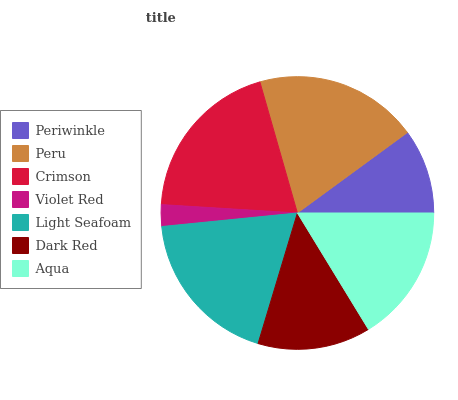Is Violet Red the minimum?
Answer yes or no. Yes. Is Crimson the maximum?
Answer yes or no. Yes. Is Peru the minimum?
Answer yes or no. No. Is Peru the maximum?
Answer yes or no. No. Is Peru greater than Periwinkle?
Answer yes or no. Yes. Is Periwinkle less than Peru?
Answer yes or no. Yes. Is Periwinkle greater than Peru?
Answer yes or no. No. Is Peru less than Periwinkle?
Answer yes or no. No. Is Aqua the high median?
Answer yes or no. Yes. Is Aqua the low median?
Answer yes or no. Yes. Is Light Seafoam the high median?
Answer yes or no. No. Is Periwinkle the low median?
Answer yes or no. No. 